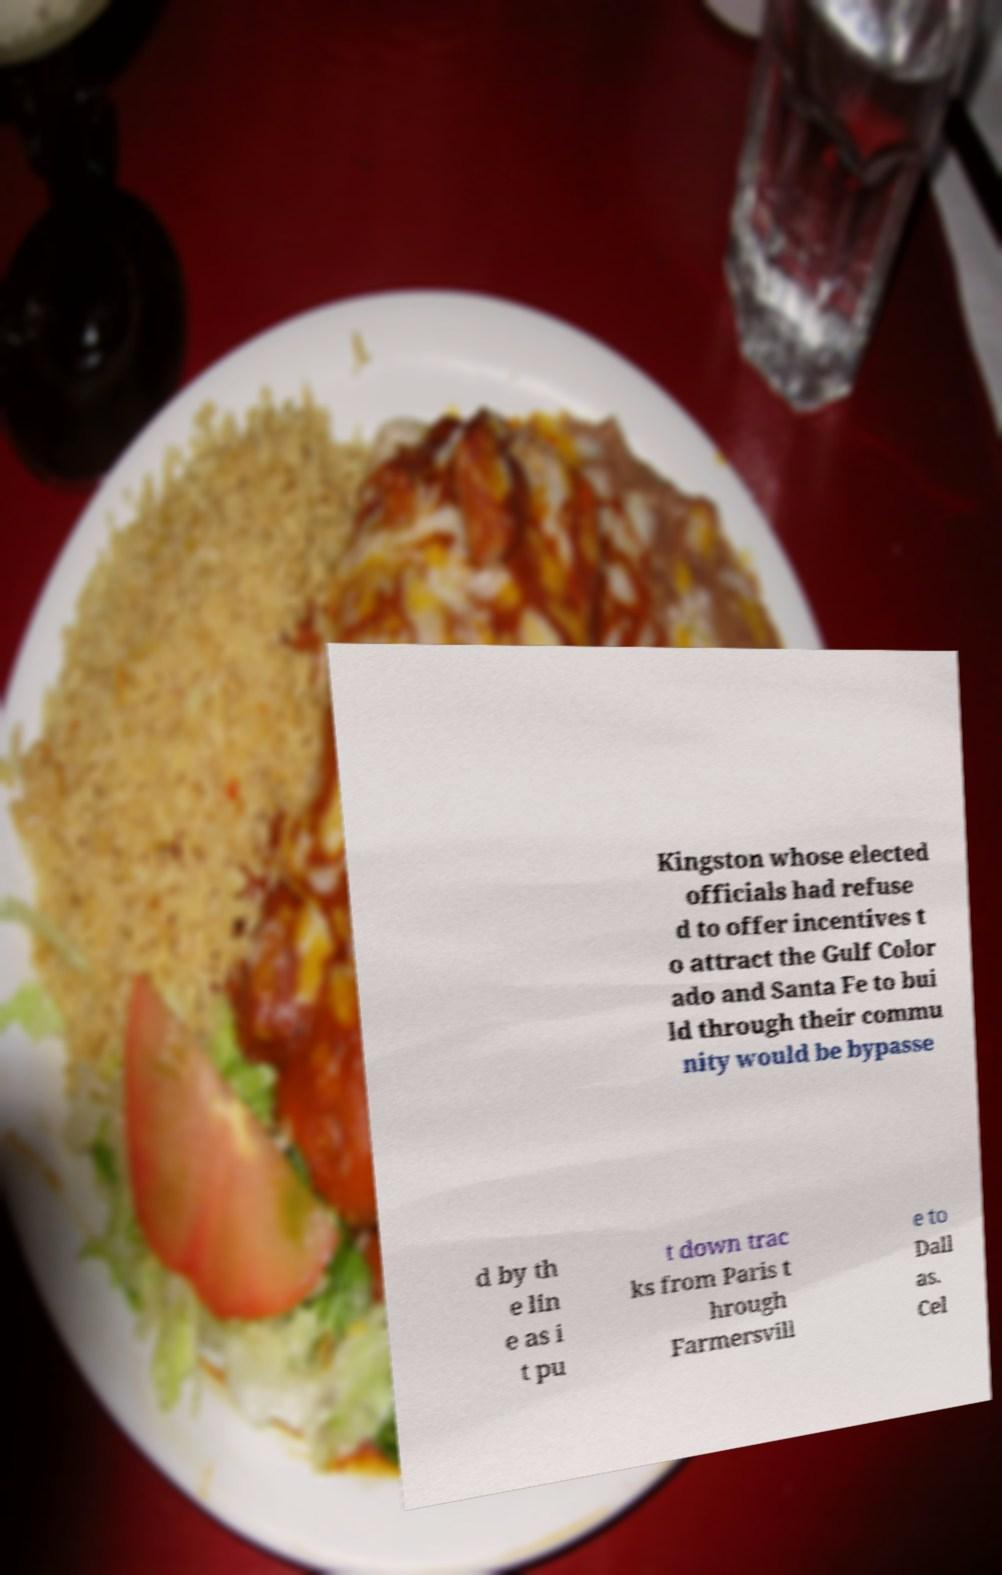Can you read and provide the text displayed in the image?This photo seems to have some interesting text. Can you extract and type it out for me? Kingston whose elected officials had refuse d to offer incentives t o attract the Gulf Color ado and Santa Fe to bui ld through their commu nity would be bypasse d by th e lin e as i t pu t down trac ks from Paris t hrough Farmersvill e to Dall as. Cel 